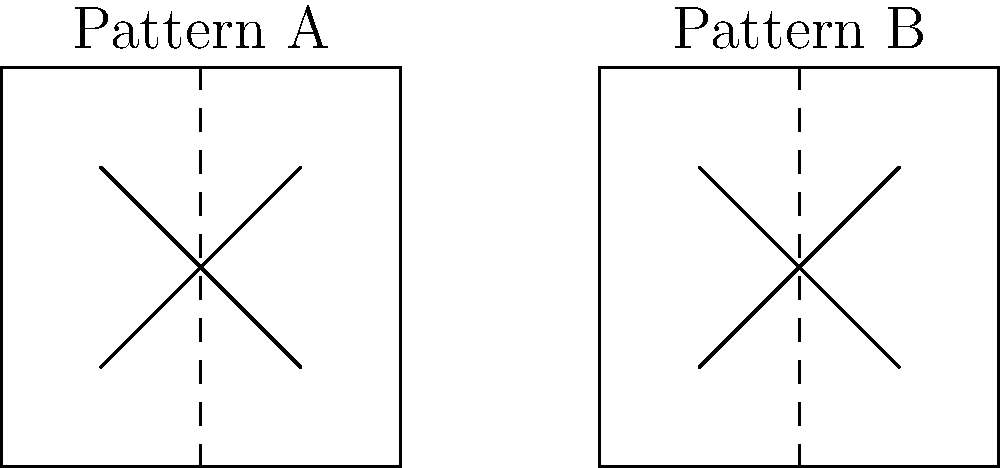At a high-end fashion boutique, you notice two exquisite designer shirts featuring similar fabric patterns. The salesperson claims the patterns are congruent. Given the graphical representation of the fabric patterns above, where Pattern A and Pattern B are shown side by side, are these patterns truly congruent? To determine if the patterns are congruent, we need to follow these steps:

1. Definition of congruence: Two geometric figures are congruent if they have the same shape and size, meaning one can be transformed into the other through a combination of translations, rotations, and reflections.

2. Examine the shapes: Both Pattern A and Pattern B are rectangles with an "X" design inside.

3. Compare dimensions:
   - The width-to-height ratio appears to be 1:1 for both patterns, indicating they are squares.
   - The "X" design in both patterns extends from corner to corner.

4. Check for transformations:
   - There is no apparent rotation or reflection between the patterns.
   - The only transformation visible is a translation (shift) to the right.

5. Assess size:
   - The patterns appear to be the same size, as they have the same height in the diagram.

6. Conclusion: Based on the given information, Pattern A and Pattern B have the same shape and size, and one can be obtained from the other through a simple translation. Therefore, they meet the criteria for congruence.
Answer: Yes, the patterns are congruent. 